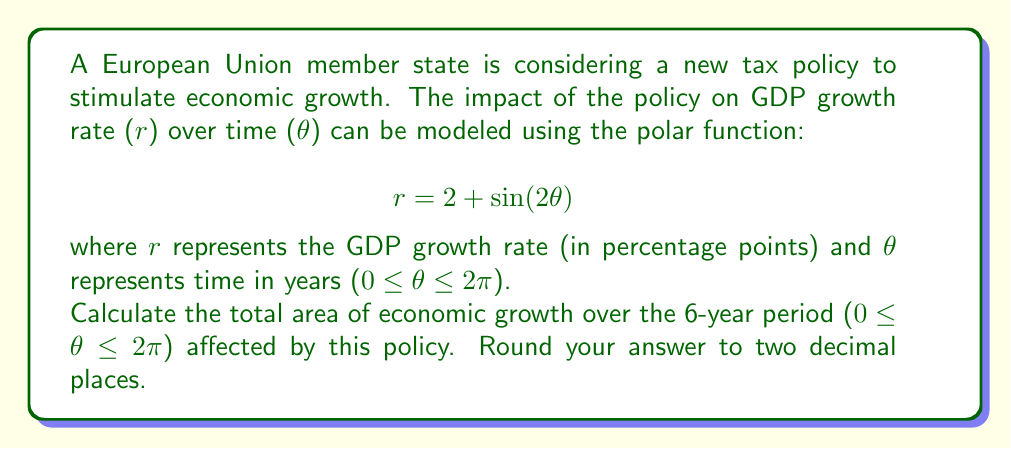Could you help me with this problem? To solve this problem, we need to calculate the area enclosed by the polar curve over one complete revolution (0 ≤ θ ≤ 2π). The formula for the area enclosed by a polar curve is:

$$A = \frac{1}{2} \int_{0}^{2\pi} r^2 d\theta$$

Let's break this down step-by-step:

1) First, we need to square our function r:
   $$r^2 = (2 + \sin(2\theta))^2 = 4 + 4\sin(2\theta) + \sin^2(2\theta)$$

2) Now, we can set up our integral:
   $$A = \frac{1}{2} \int_{0}^{2\pi} (4 + 4\sin(2\theta) + \sin^2(2\theta)) d\theta$$

3) Let's integrate each term separately:
   
   a) $\int_{0}^{2\pi} 4 d\theta = 4\theta |_{0}^{2\pi} = 8\pi$
   
   b) $\int_{0}^{2\pi} 4\sin(2\theta) d\theta = -2\cos(2\theta) |_{0}^{2\pi} = 0$
   
   c) For $\int_{0}^{2\pi} \sin^2(2\theta) d\theta$, we can use the identity $\sin^2(x) = \frac{1}{2}(1 - \cos(2x))$:
      
      $$\int_{0}^{2\pi} \sin^2(2\theta) d\theta = \int_{0}^{2\pi} \frac{1}{2}(1 - \cos(4\theta)) d\theta = \frac{1}{2}\theta - \frac{1}{8}\sin(4\theta) |_{0}^{2\pi} = \pi$$

4) Adding these results:
   $$A = \frac{1}{2} (8\pi + 0 + \pi) = \frac{9\pi}{2}$$

5) Converting to a decimal and rounding to two decimal places:
   $$A \approx 14.14$$
Answer: 14.14 square percentage-years 